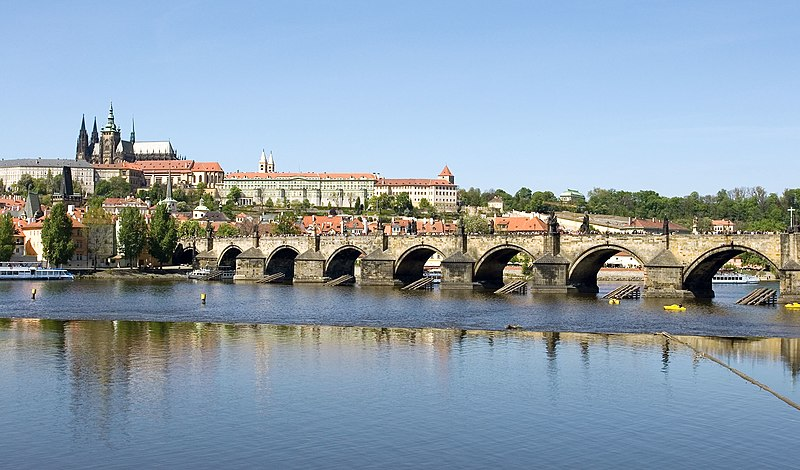How does the Charles Bridge change throughout the day and night? The Charles Bridge transforms dramatically from dawn to dusk. In the early morning, it is tranquil and bathed in soft light, perfect for a reflective walk. By mid-morning, tourists begin to populate the bridge, capturing photographs and admiring the view. Street artists and musicians add to the lively atmosphere, entertaining passersby with their talents. As the day turns into the evening, the crowds thin out, and the bridge takes on a more intimate feel. Under the night sky, illuminated by street lamps and the lights from nearby buildings, the bridge becomes a romantic backdrop for evening strolls. The statues cast long, mysterious shadows, and the reflection in the calm, dark river amplifies the bridge's enchanting allure. Create an imaginary scenario where the Charles Bridge is a portal to another dimension. As twilight descends upon Prague, the Charles Bridge reveals its hidden secret - an ancient mechanism embedded in the bridge's foundation activates, opening a shimmering portal in the center. Stepping through the portal, one finds themselves in an alternate dimension where medieval Prague meets futuristic technology. The statues on the bridge become guardians of this new realm, guiding travelers through vibrant streets filled with a mixture of historical grandeur and advanced innovation. Buildings tower into the sky, yet reflect the gothic and baroque styles. The Vltava River flows with luminescent water, and the air hums with a blend of old-world charm and modernity, creating a fantastical juxtaposition of eras. 